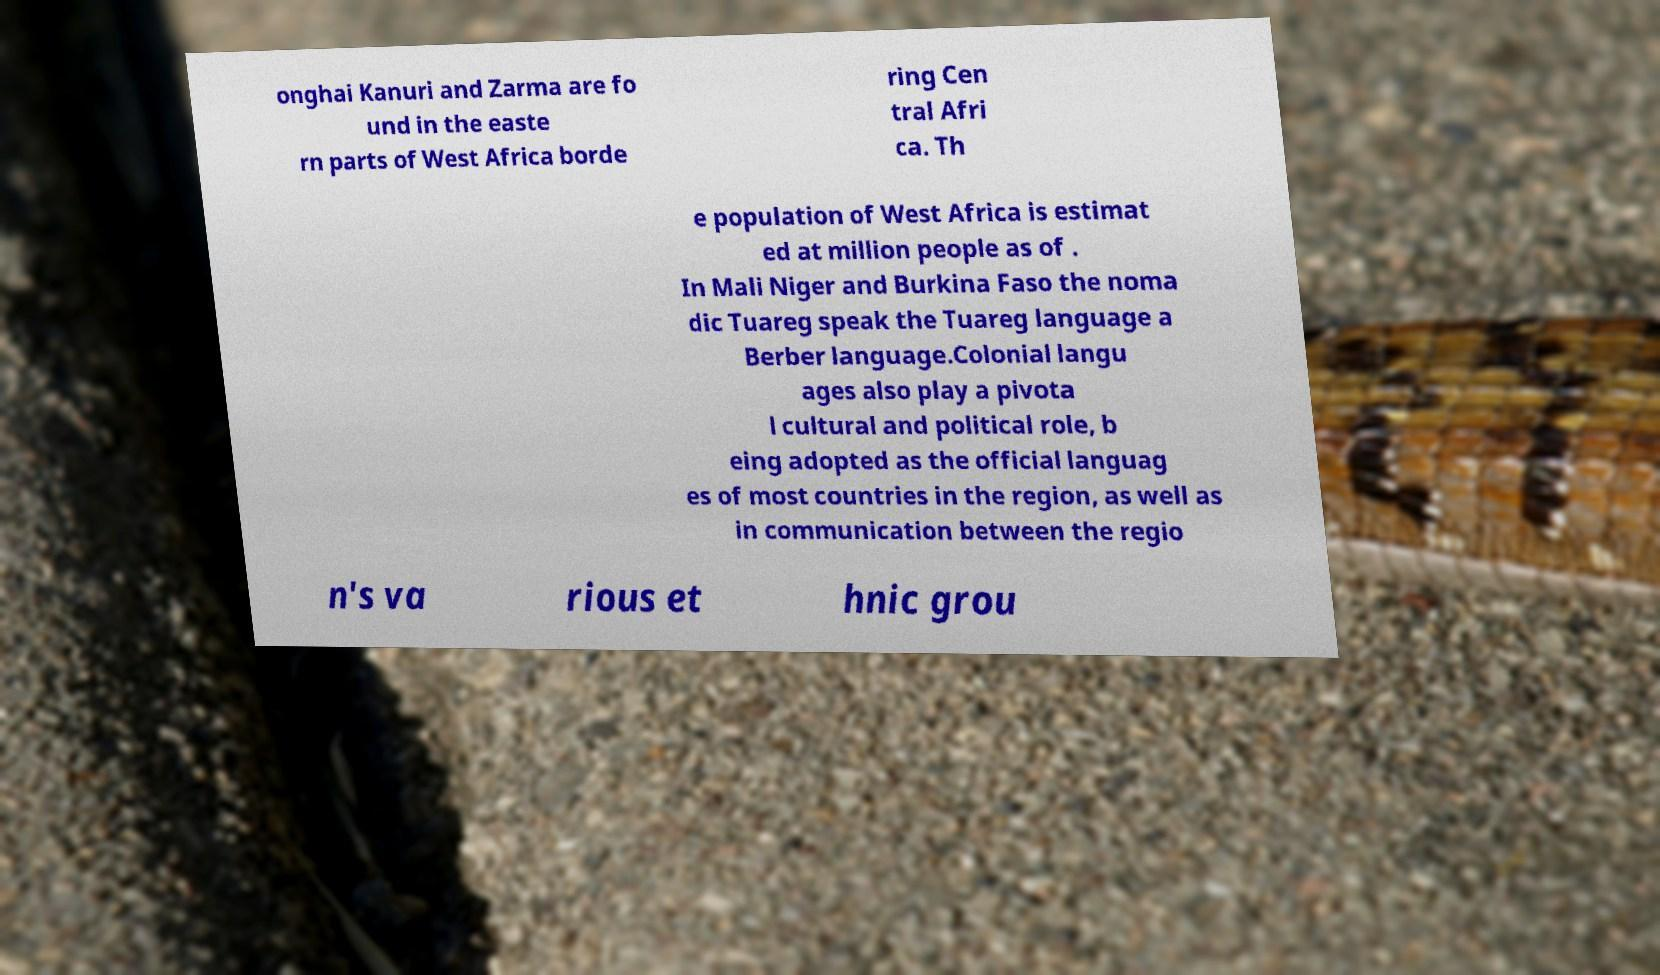Please identify and transcribe the text found in this image. onghai Kanuri and Zarma are fo und in the easte rn parts of West Africa borde ring Cen tral Afri ca. Th e population of West Africa is estimat ed at million people as of . In Mali Niger and Burkina Faso the noma dic Tuareg speak the Tuareg language a Berber language.Colonial langu ages also play a pivota l cultural and political role, b eing adopted as the official languag es of most countries in the region, as well as in communication between the regio n's va rious et hnic grou 